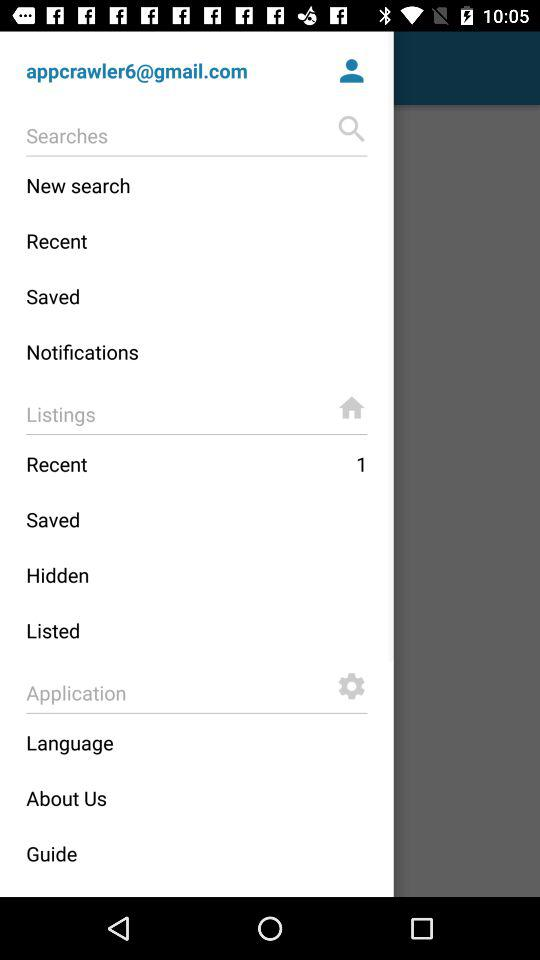What is the number of pending recent listings? The number of pending recent listings is 1. 